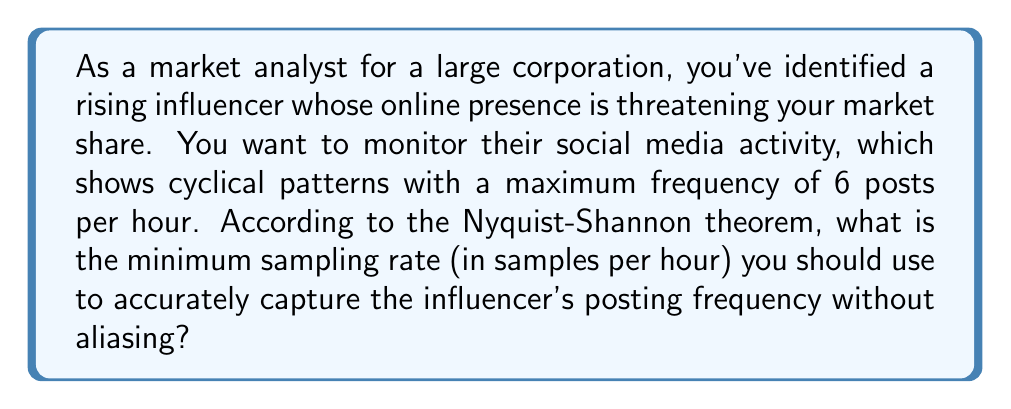What is the answer to this math problem? To solve this problem, we need to apply the Nyquist-Shannon theorem. This theorem states that to accurately reconstruct a signal, the sampling rate must be at least twice the highest frequency component in the signal. This minimum sampling rate is called the Nyquist rate.

Given:
- The maximum frequency of the influencer's posts is 6 posts per hour.

Let's apply the Nyquist-Shannon theorem:

1. The Nyquist rate is given by the formula:

   $$f_s \geq 2f_{max}$$

   Where:
   $f_s$ is the sampling rate
   $f_{max}$ is the maximum frequency in the signal

2. Substituting the given maximum frequency:

   $$f_s \geq 2 \cdot 6$$
   $$f_s \geq 12$$

3. Therefore, the minimum sampling rate should be 12 samples per hour.

This means that to accurately capture the influencer's posting frequency without aliasing, you need to sample their social media activity at least 12 times per hour, or once every 5 minutes.

By sampling at this rate or higher, you ensure that you can accurately reconstruct the influencer's posting patterns and respond effectively to protect your market share.
Answer: The minimum sampling rate is 12 samples per hour. 